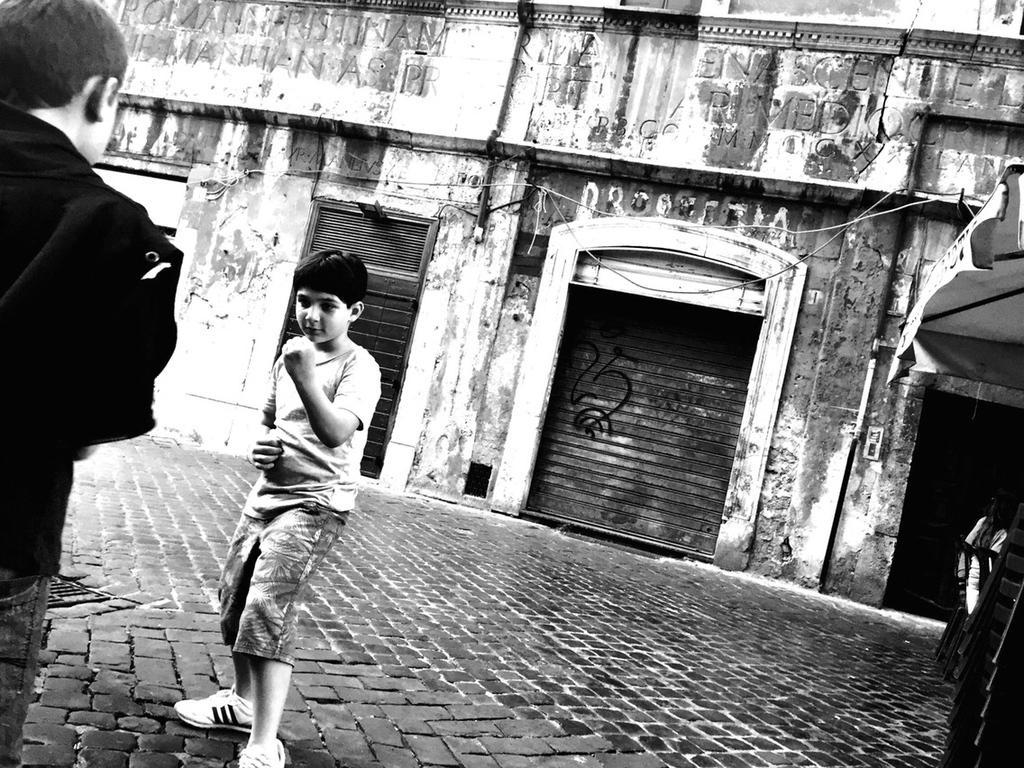Can you describe this image briefly? This is a black and white image. There is a boy. On the left side there is another person. In the back there are buildings with shutter. Also something is written on the buildings. 